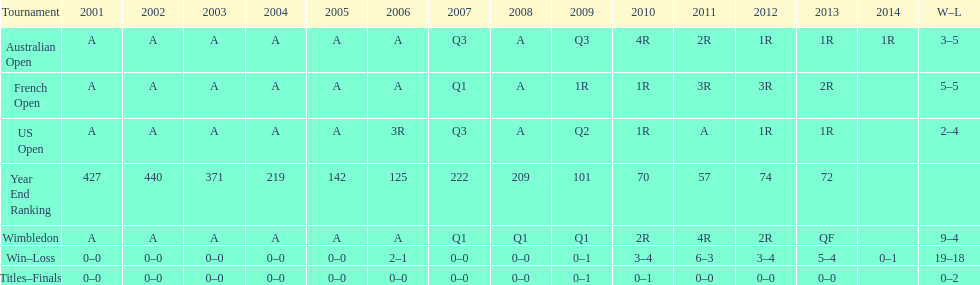Which years was a ranking below 200 achieved? 2005, 2006, 2009, 2010, 2011, 2012, 2013. 